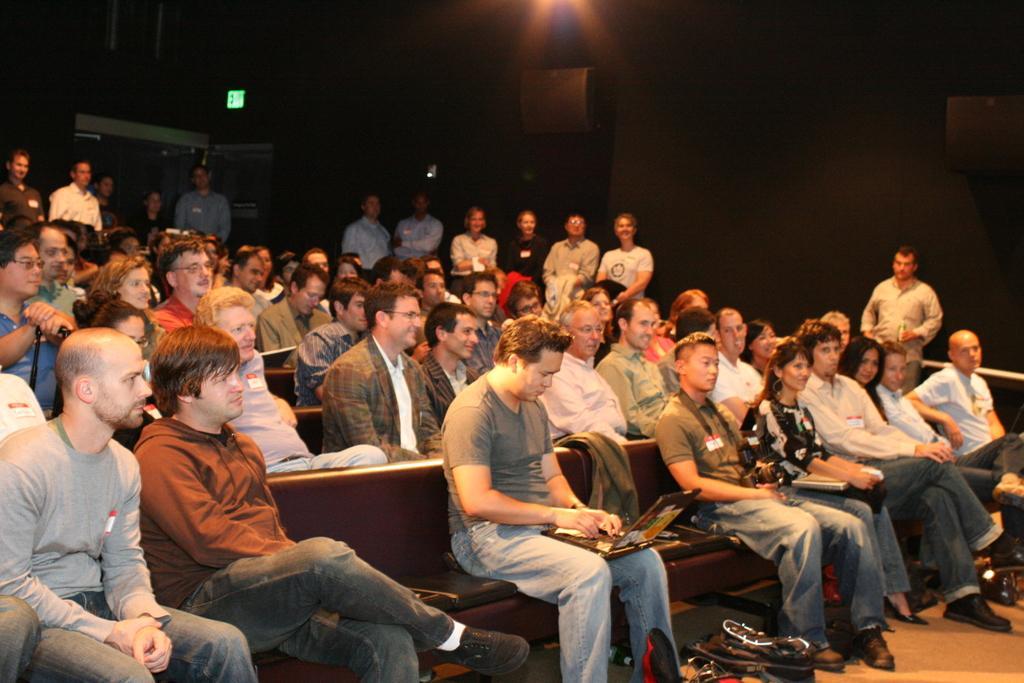Can you describe this image briefly? This picture describes about group of people, few people are seated and few are standing, and we can see few people are holding laptops. 